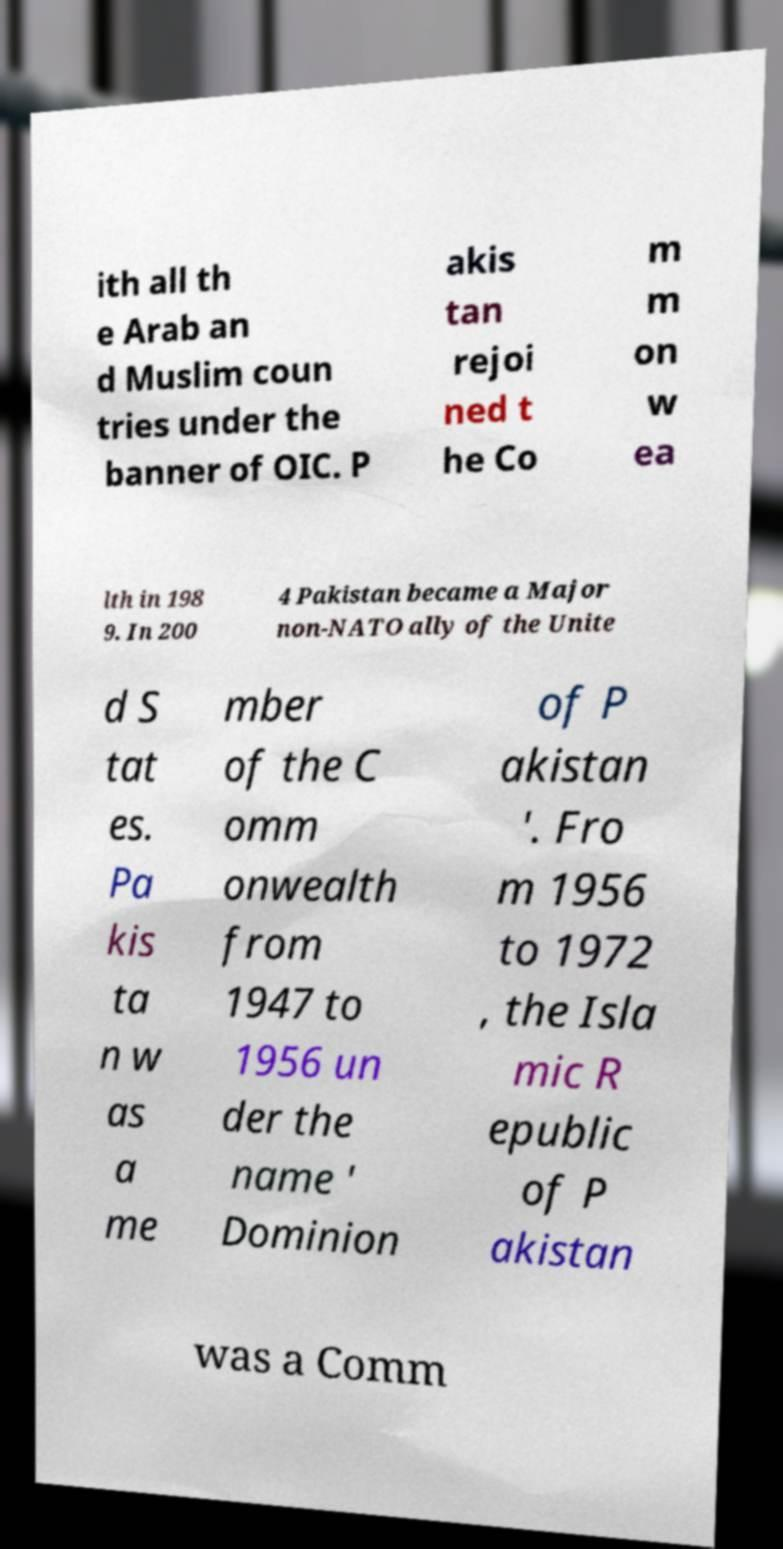I need the written content from this picture converted into text. Can you do that? ith all th e Arab an d Muslim coun tries under the banner of OIC. P akis tan rejoi ned t he Co m m on w ea lth in 198 9. In 200 4 Pakistan became a Major non-NATO ally of the Unite d S tat es. Pa kis ta n w as a me mber of the C omm onwealth from 1947 to 1956 un der the name ' Dominion of P akistan '. Fro m 1956 to 1972 , the Isla mic R epublic of P akistan was a Comm 